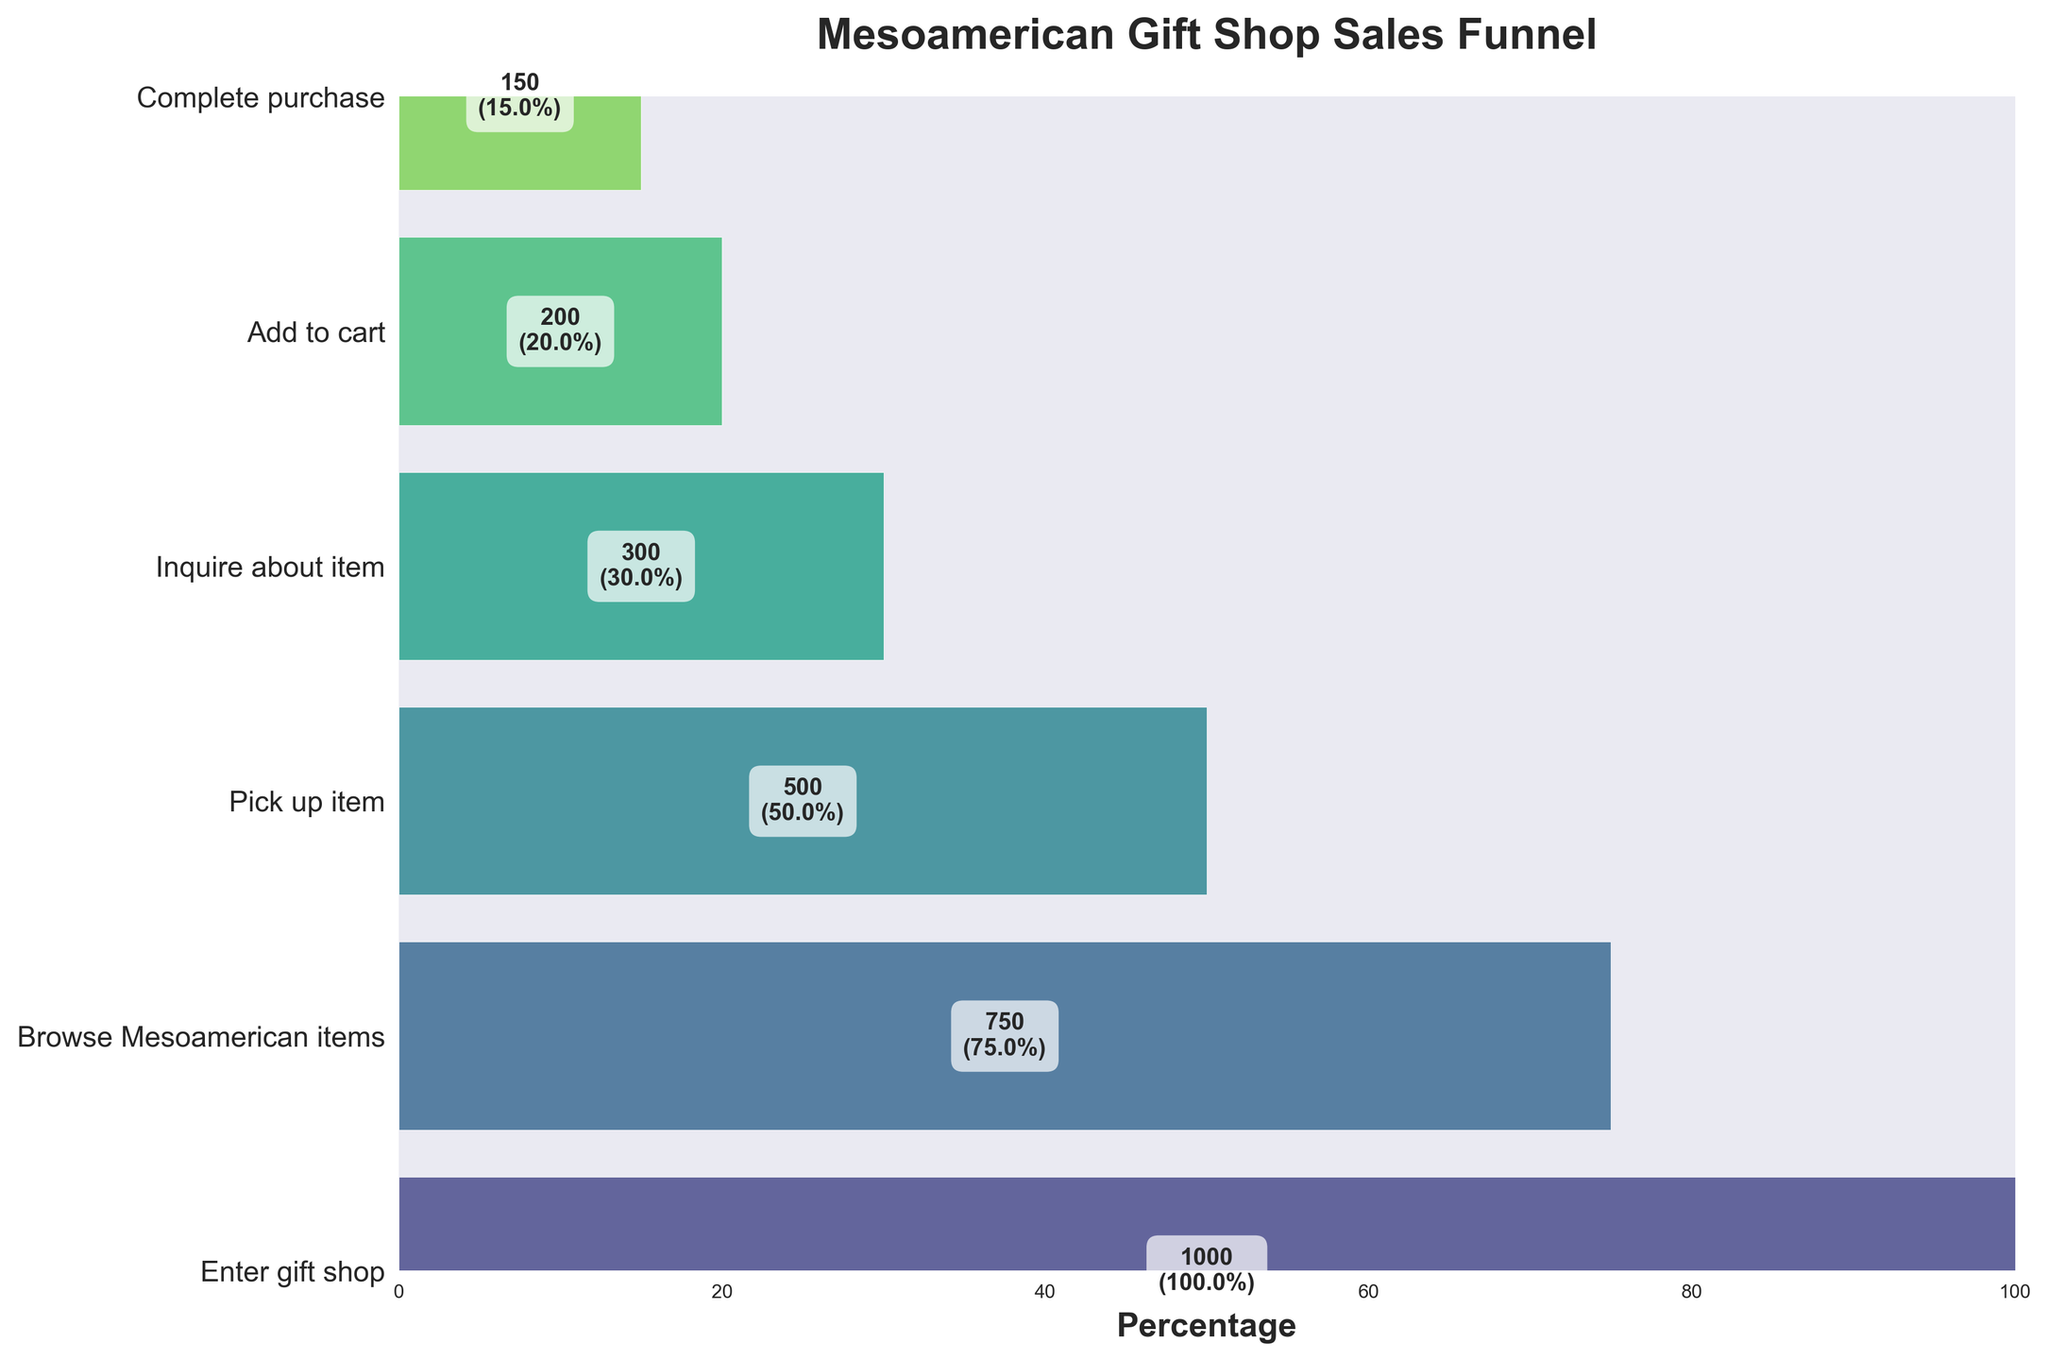What stage has the highest number of visitors? Identify the stage with the largest number of visitors. The "Enter gift shop" stage has 1000 visitors, which is the highest.
Answer: Enter gift shop Which stage has the fewest visitors? Compare the visitor counts for each stage. The "Complete purchase" stage has 150 visitors, which is the fewest.
Answer: Complete purchase What is the percentage of visitors who add to cart but do not complete the purchase? Subtract the percentage of those who complete the purchase from those who add to cart. 20% - 15% = 5%.
Answer: 5% How many more visitors browse Mesoamerican items compared to those who complete a purchase? Subtract the number of visitors who complete a purchase from those who browse items. 750 - 150 = 600.
Answer: 600 What is the ratio of visitors who inquire about an item to those who pick up an item? Divide the number of visitors who inquire by the number who pick up an item. 300 / 500 = 0.6.
Answer: 0.6 Which stage has exactly half the visitors of the "Enter gift shop" stage? Find the stage where the visitor count is 50% of the "Enter gift shop" stage. 1000 * 0.5 = 500. This is the "Pick up item" stage.
Answer: Pick up item How many stages are there in the funnel? Count the number of unique stages presented in the figure. There are six stages: Enter gift shop, Browse Mesoamerican items, Pick up item, Inquire about item, Add to cart, Complete purchase.
Answer: Six What percentage of visitors inquire about an item after picking it up? Divide the number of visitors who inquire about the item by those who pick it up and multiply by 100. (300 / 500) * 100 = 60%.
Answer: 60% By how much does the percentage decrease from the stage "Pick up item" to "Complete purchase"? Subtract the percentage of those who complete the purchase from the percentage of those who pick up an item. 50% - 15% = 35%.
Answer: 35% Which stage sees a 50% drop in visitor percentage from the previous stage? Compare the percentage drops between consecutive stages. The "Pick up item" stage (50%) showcases exactly a 50% reduction from the "Browse Mesoamerican items" stage (75%).
Answer: Pick up item 